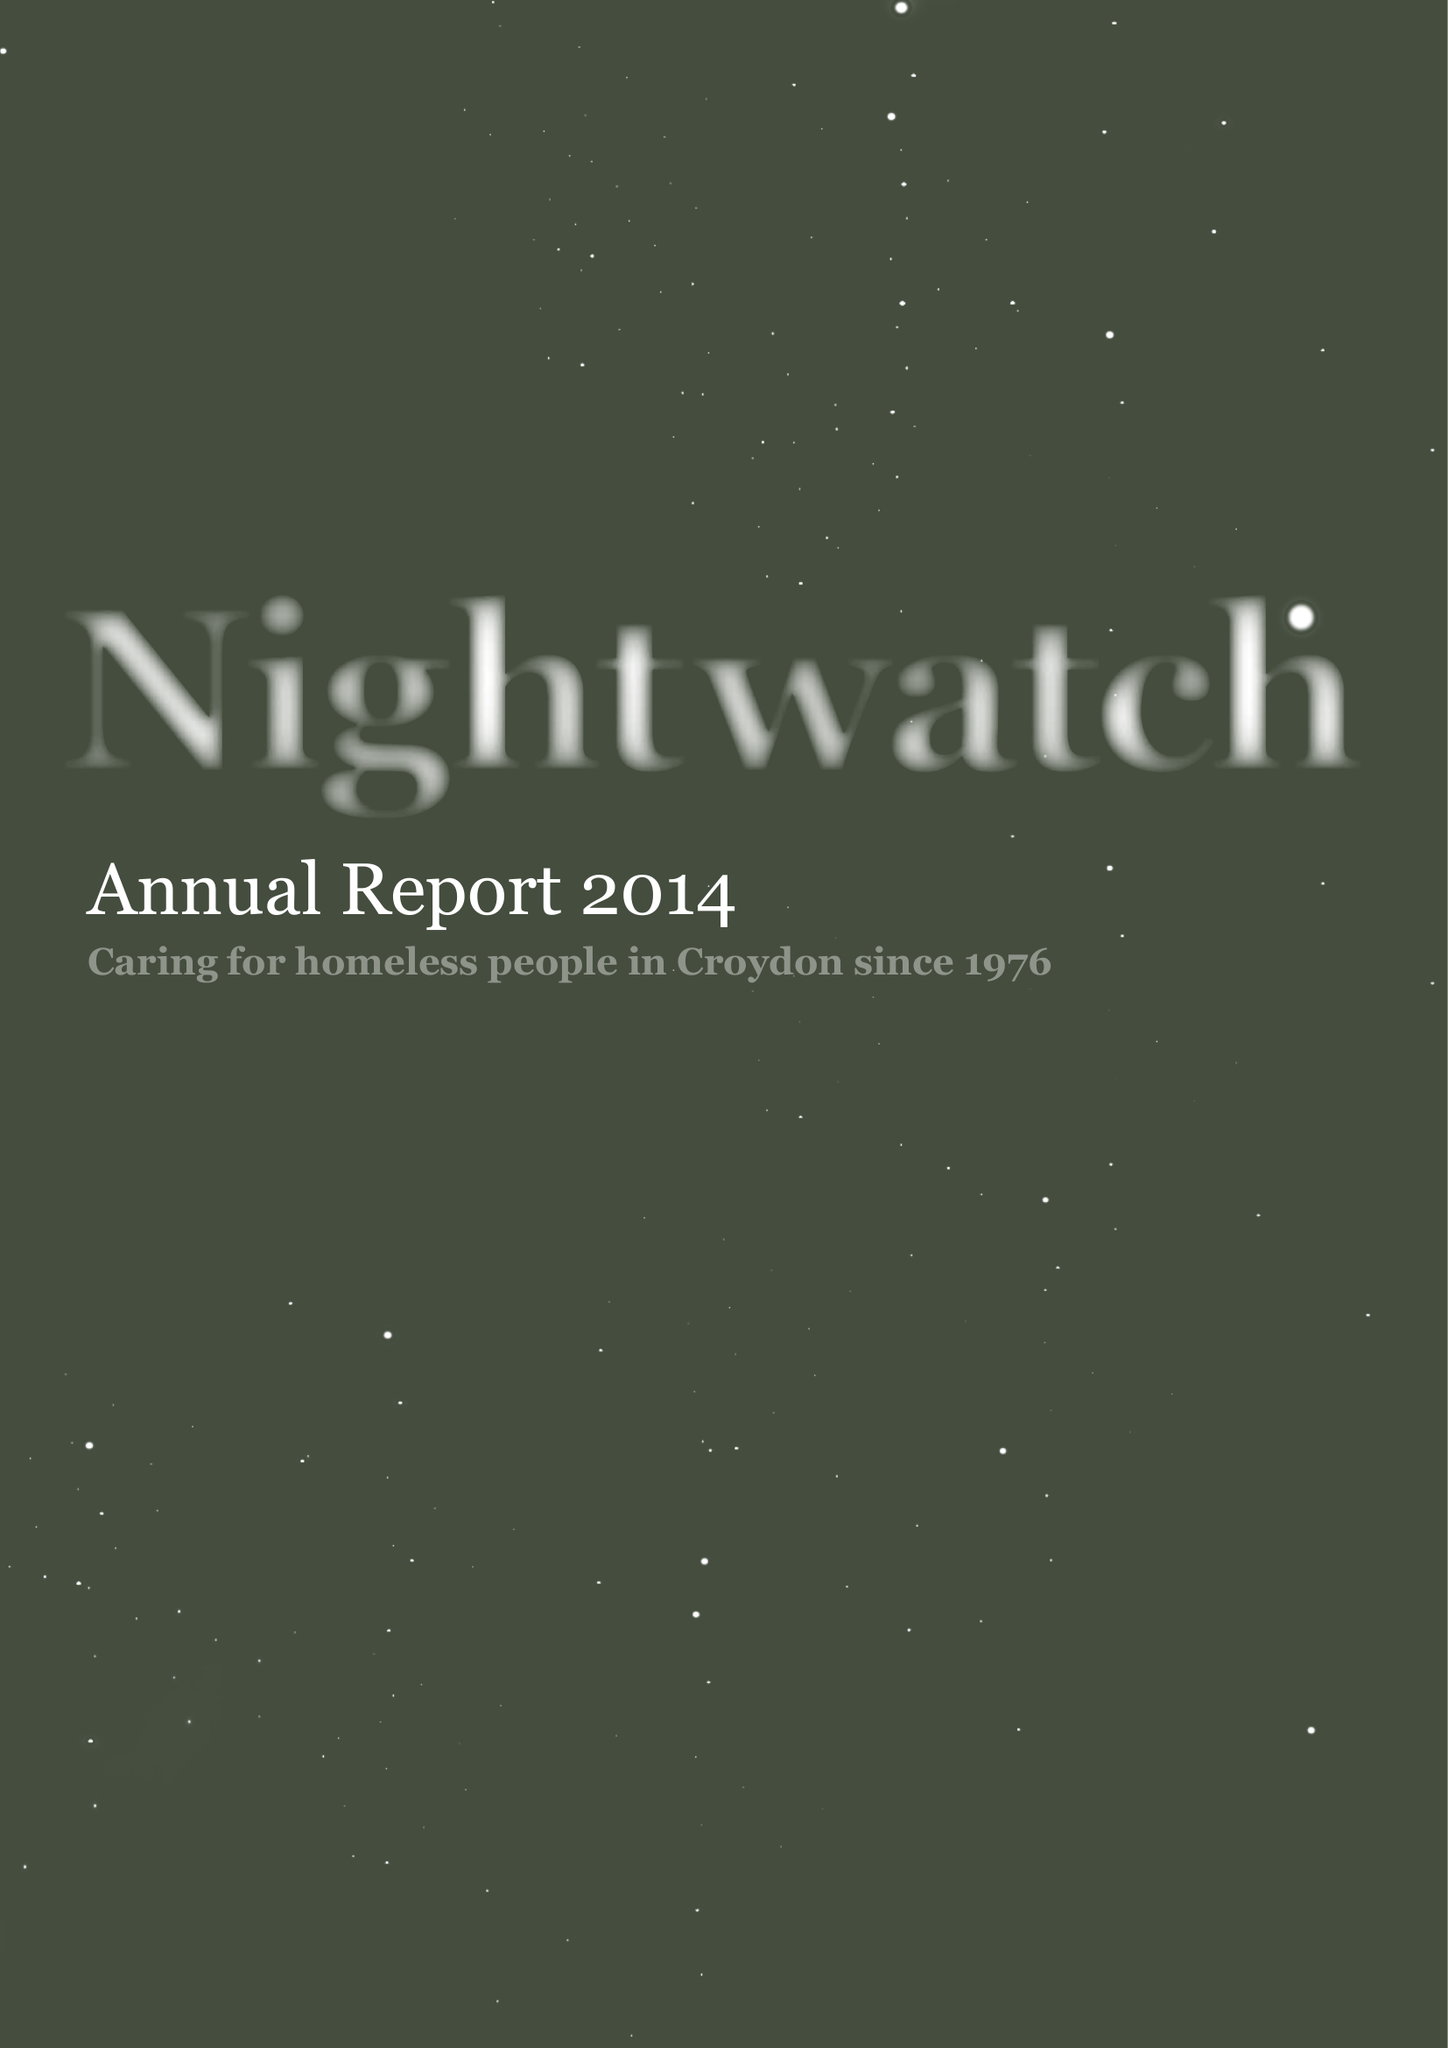What is the value for the address__postcode?
Answer the question using a single word or phrase. SE23 3ZH 